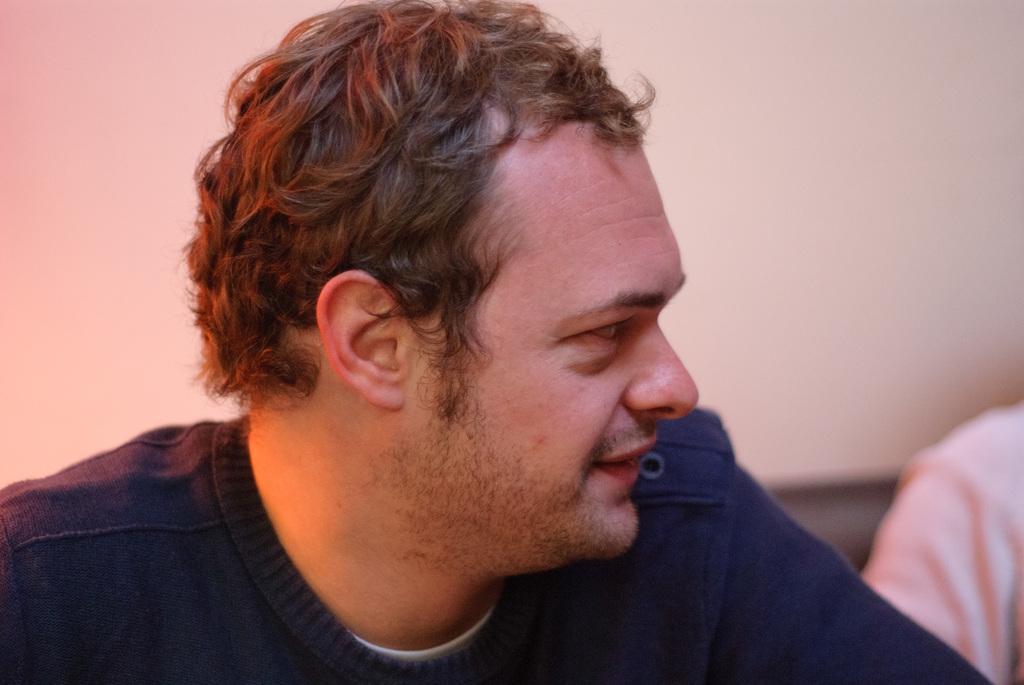How would you summarize this image in a sentence or two? Here I can see a man wearing a blue color dress and smiling by looking at the right side. On the right side, I can see another person's hand. In the background there is a wall. 